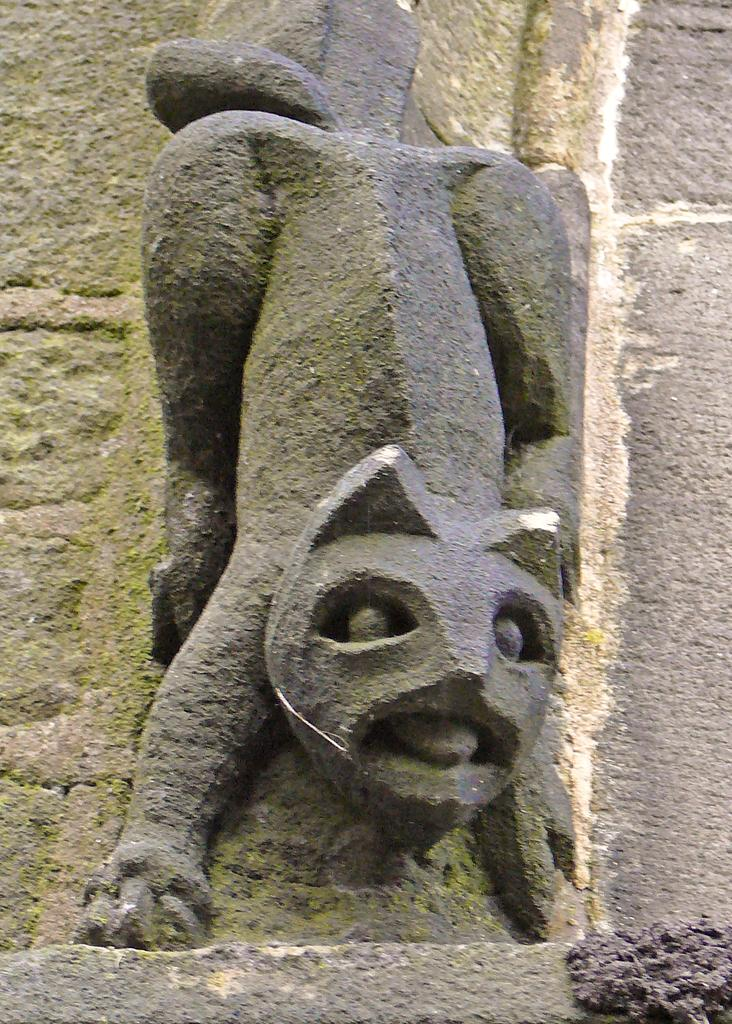What is the main subject of the image? There is a sculpture of an animal in the image. What can be seen behind the sculpture? The background of the image appears to be a wall. Where is the cave located in the image? There is no cave present in the image; it features a sculpture of an animal and a wall as the background. What type of dock can be seen in the image? There is no dock present in the image. 